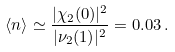<formula> <loc_0><loc_0><loc_500><loc_500>\langle n \rangle \simeq \frac { | \chi _ { 2 } ( 0 ) | ^ { 2 } } { | \nu _ { 2 } ( 1 ) | ^ { 2 } } = 0 . 0 3 \, .</formula> 